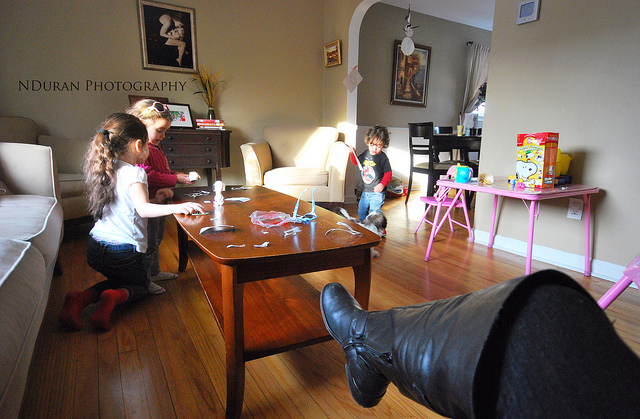Please transcribe the text in this image. NDURAN PHOTOGRAPHY 